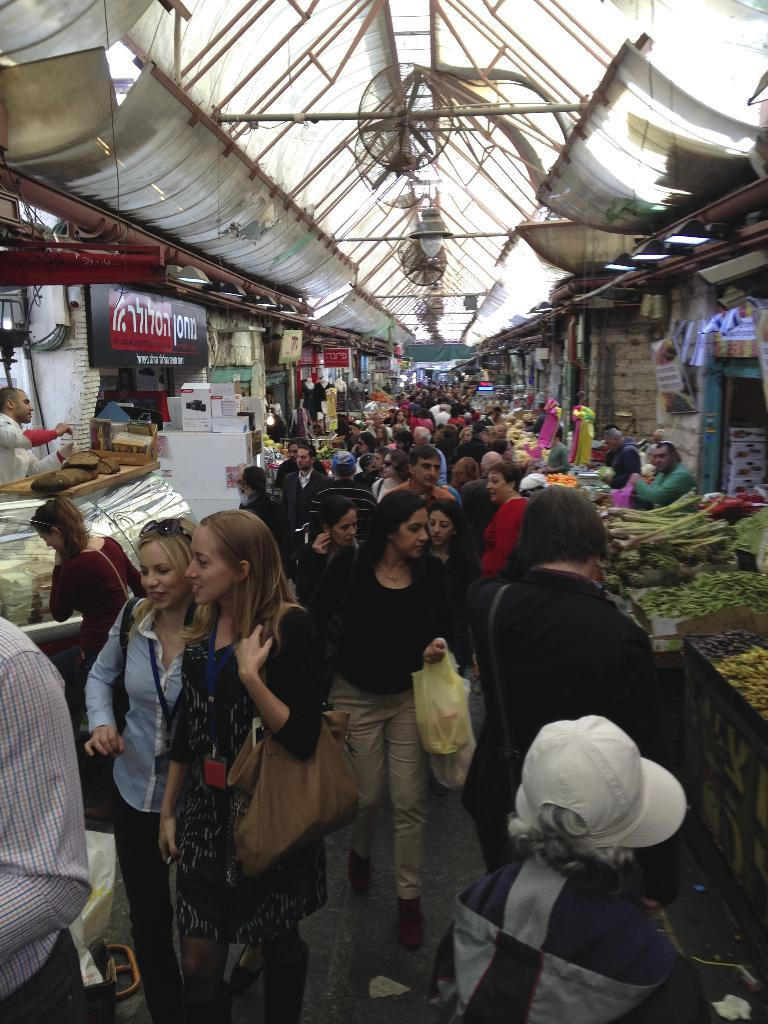How many people are in the image? There is a group of people standing in the image. What type of lighting is present in the image? There are lights in the image. What type of cooling devices are present in the image? There are fans in the image. What type of structures are present in the image? There are stalls in the image. What type of signage is present in the image? There are boards in the image. What type of appliance is present in the image? There is a display refrigerator in the image. What other objects are present in the image? There are other objects in the image. What type of arithmetic problem is being solved by the minister in the image? There is no minister or arithmetic problem present in the image. 